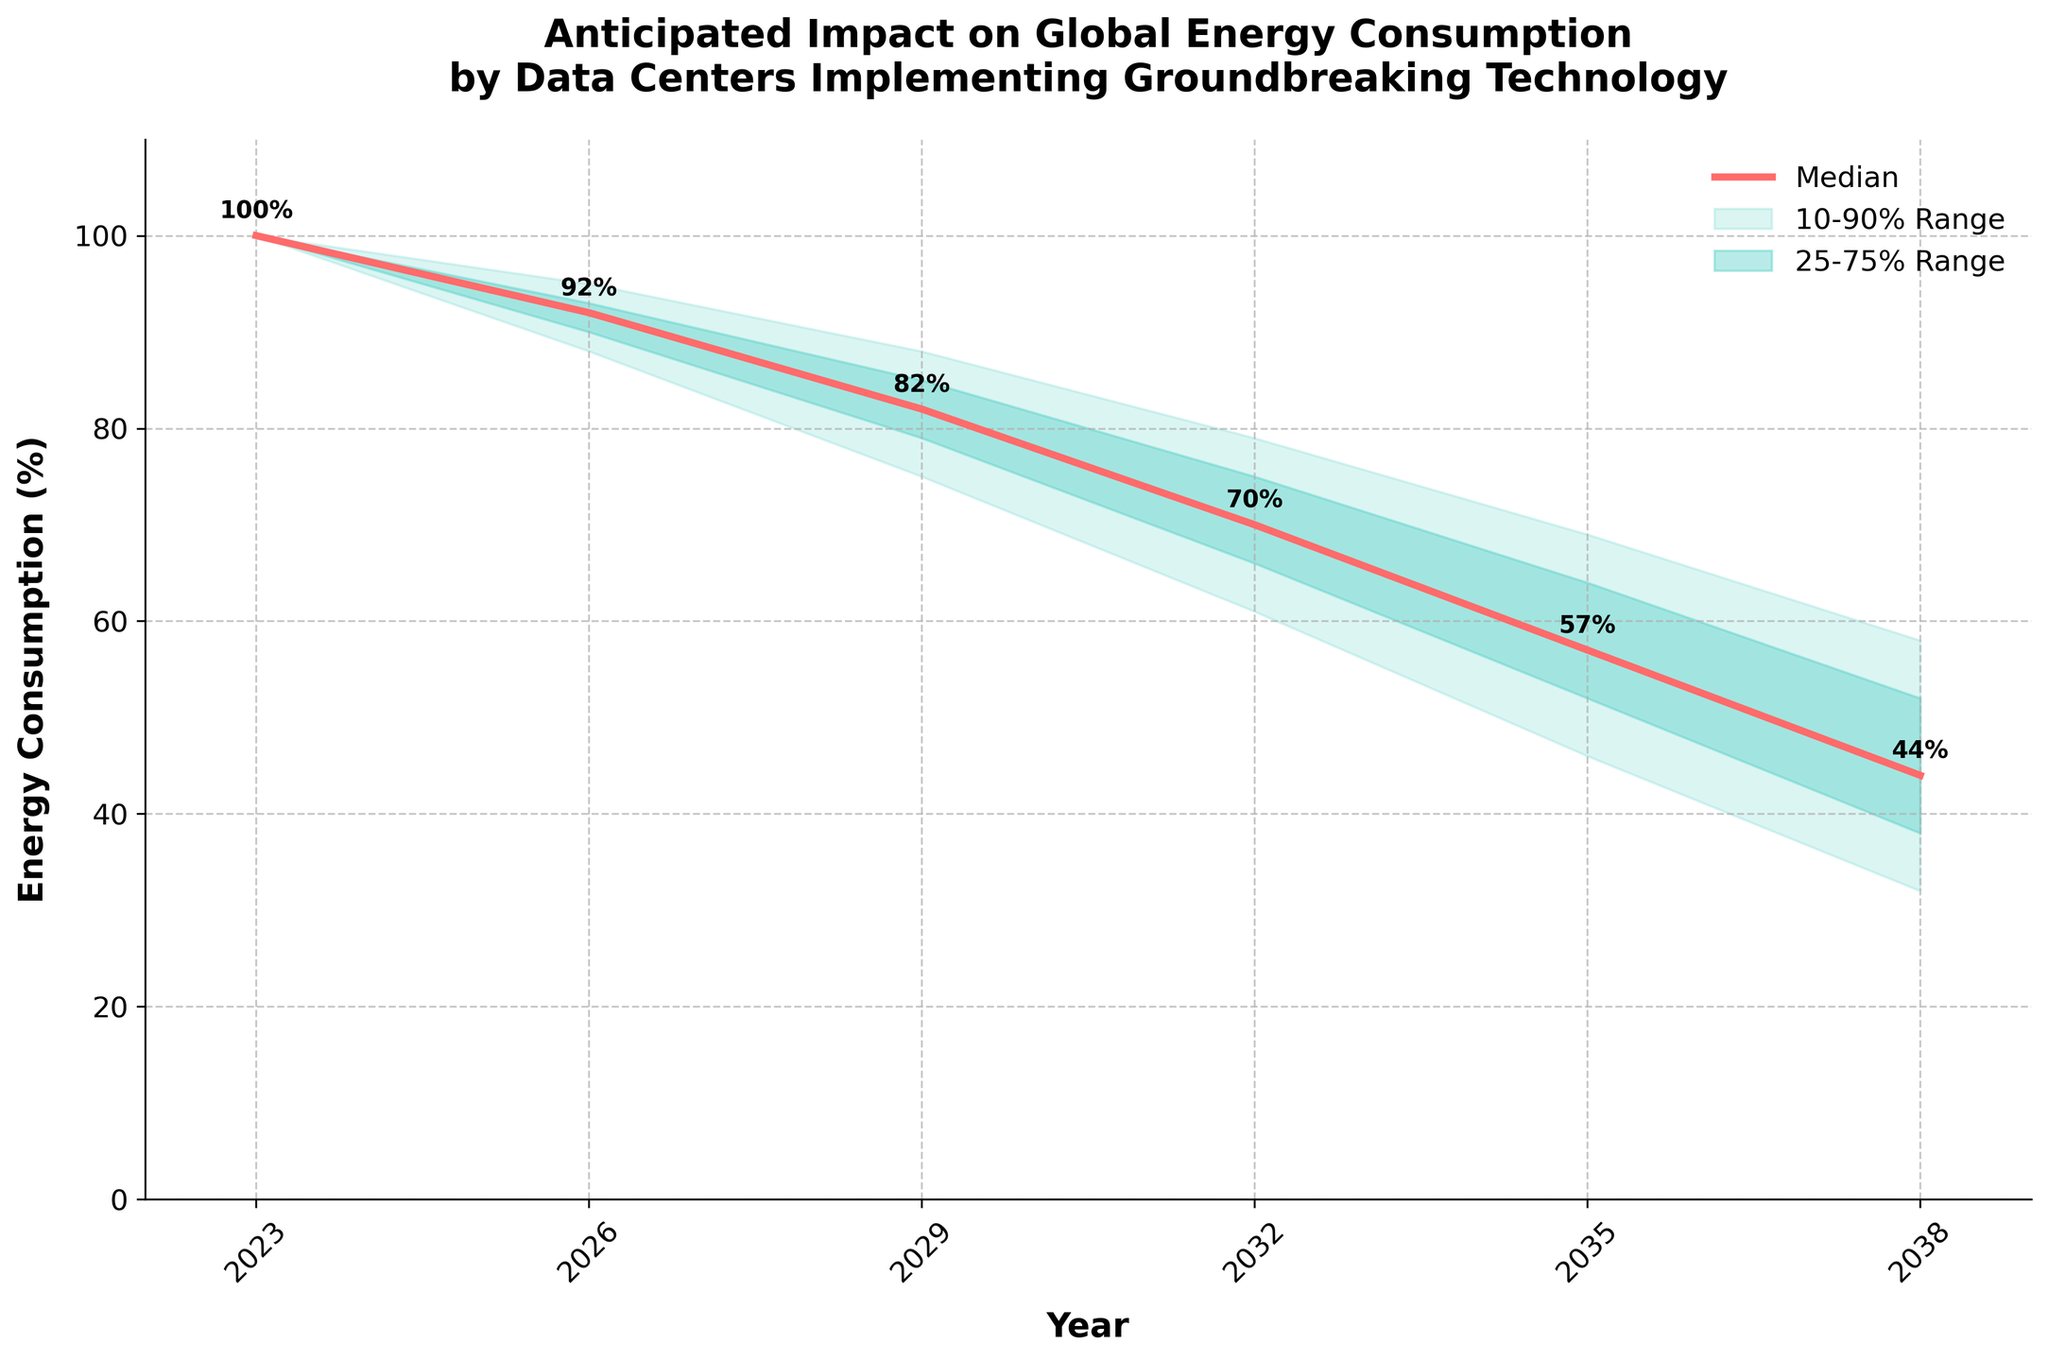Which year has the lowest median energy consumption prediction? The year with the lowest value on the median line needs to be identified. The median energy consumption in 2038 is the lowest at 44%.
Answer: 2038 What is the title of the chart? Read the title at the top of the chart. It says: "Anticipated Impact on Global Energy Consumption by Data Centers Implementing Groundbreaking Technology".
Answer: Anticipated Impact on Global Energy Consumption by Data Centers Implementing Groundbreaking Technology How many years are displayed in the chart? Count the number of ticks/labels on the x-axis representing different years. The years displayed are 2023, 2026, 2029, 2032, 2035, and 2038, totaling 6.
Answer: 6 What range of years is covered in this fan chart? Observe the first and last year on the x-axis. The range starts at 2023 and ends at 2038.
Answer: 2023 to 2038 What is the 10-90% range of energy consumption in 2032? Refer to the bounds of the shaded region for the given year. The 10-90% range for 2032 is between 61% (lower bound) and 79% (upper bound).
Answer: 61% to 79% By how much does the median energy consumption decrease from 2023 to 2026? Subtract the median value in 2026 from the median value in 2023: 100% - 92% = 8%.
Answer: 8% What is the width of the 10-90% range in 2035? Calculate the difference between the upper and lower bounds of the 10-90% range in 2035: 69% - 46% = 23%.
Answer: 23% How does the expected energy consumption in 2026 compare to 2029 in terms of the median estimate? Compare the median values for both years: 92% in 2026 and 82% in 2029, showing that the median energy consumption decreases.
Answer: Decreases What is the percentage reduction in the median energy consumption between 2023 and 2038? Subtract the median energy consumption in 2038 from the value in 2023 and divide by the 2023 value to find a percentage: (100% - 44%) / 100% = 56%.
Answer: 56% What does the shaded area represent in the context of the chart? The shaded areas indicate the uncertainty in predictions, where the darker shade represents the 25-75% range and the lighter shade represents the 10-90% range.
Answer: Prediction uncertainty 